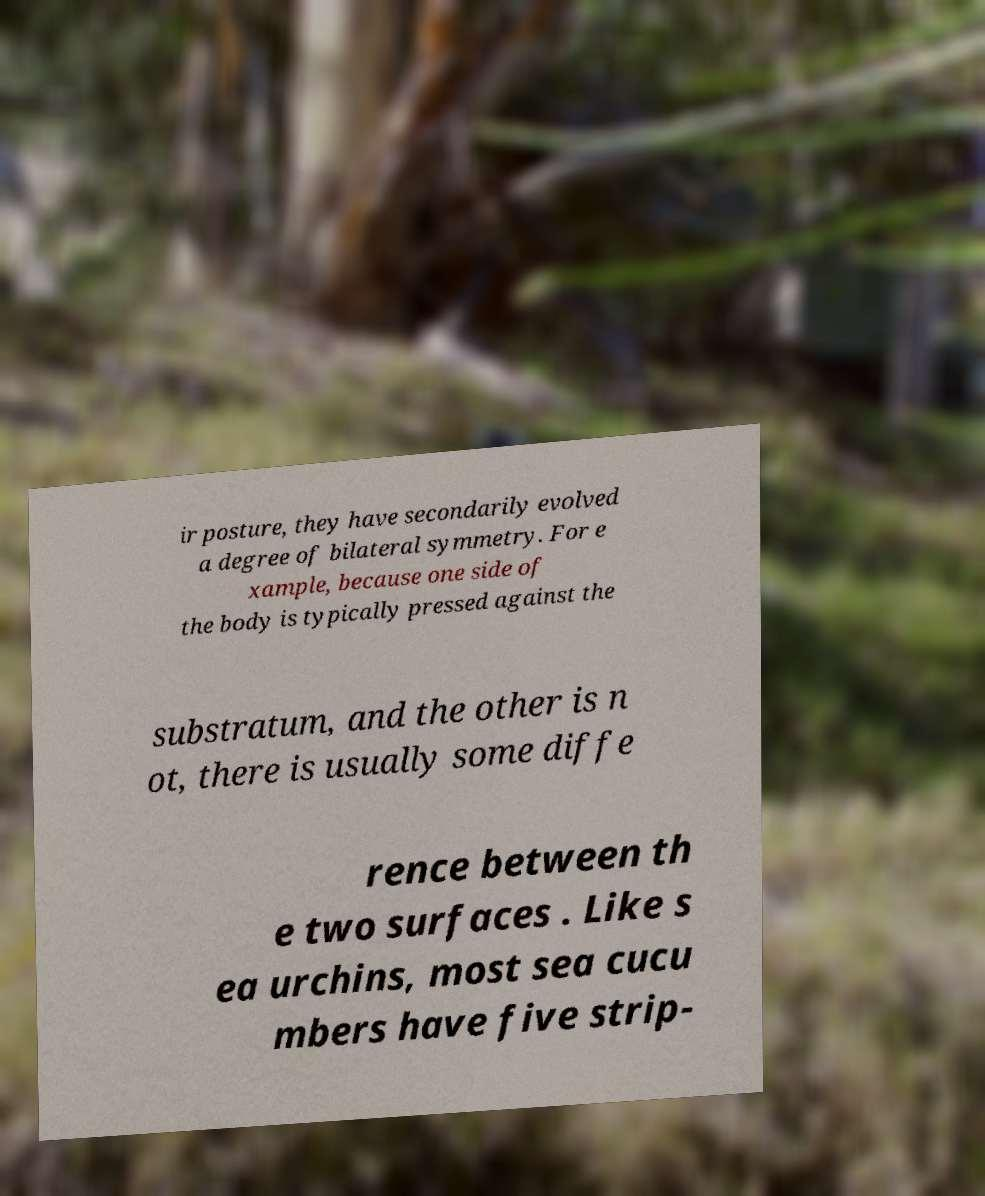Could you assist in decoding the text presented in this image and type it out clearly? ir posture, they have secondarily evolved a degree of bilateral symmetry. For e xample, because one side of the body is typically pressed against the substratum, and the other is n ot, there is usually some diffe rence between th e two surfaces . Like s ea urchins, most sea cucu mbers have five strip- 